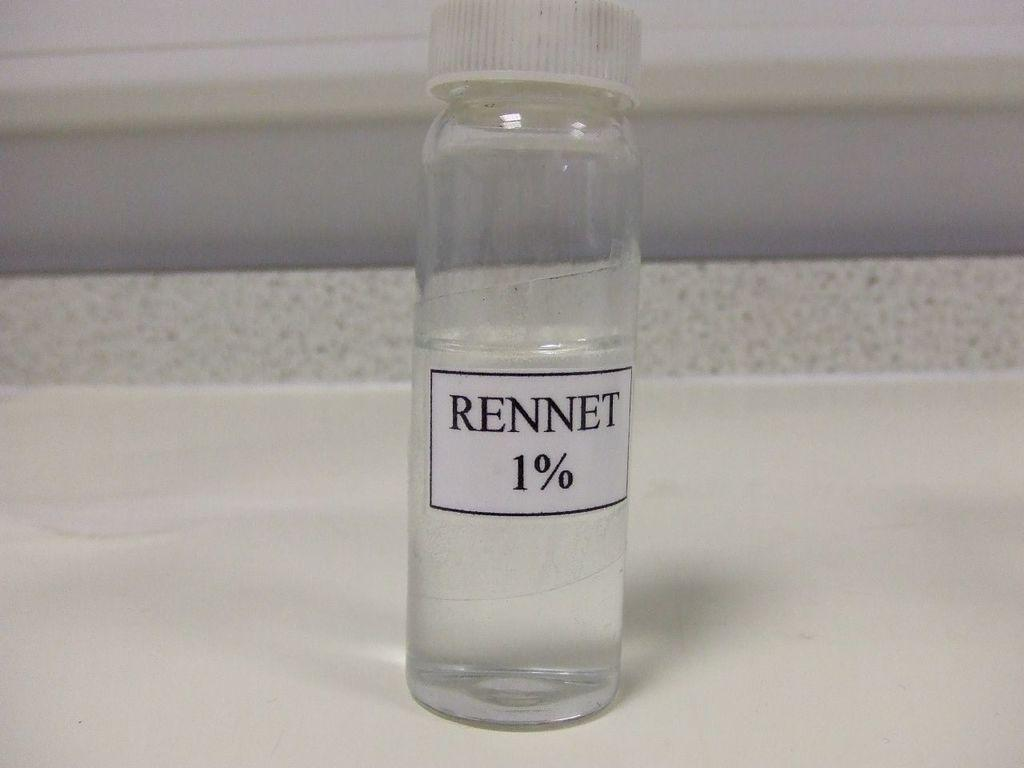What is the color of the bottle in the image? The bottle in the image is white. Is there anything attached to the bottle? Yes, there is a white color sticker attached to the bottle. What is written on the sticker? The word "RENNET" is written on the sticker. How many children are wearing masks while playing with icicles in the image? There are no children, masks, or icicles present in the image. 